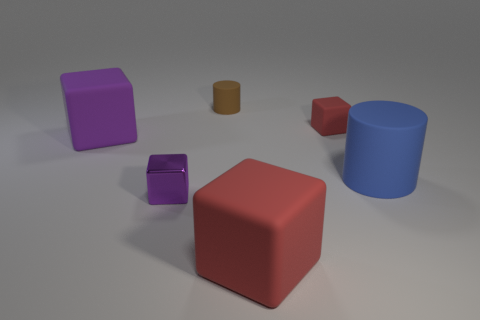How many blue objects are small rubber objects or objects?
Give a very brief answer. 1. Does the large thing that is to the left of the large red object have the same shape as the red thing in front of the large cylinder?
Your answer should be compact. Yes. What number of other things are made of the same material as the tiny brown cylinder?
Keep it short and to the point. 4. Are there any blue cylinders right of the large rubber cube that is left of the matte cylinder that is to the left of the large red cube?
Your answer should be very brief. Yes. Are the large blue cylinder and the tiny purple cube made of the same material?
Provide a succinct answer. No. What material is the big block that is in front of the matte cube on the left side of the metal thing?
Offer a terse response. Rubber. There is a red cube in front of the tiny purple block; what is its size?
Make the answer very short. Large. There is a big thing that is both to the left of the tiny red block and behind the purple metal object; what is its color?
Keep it short and to the point. Purple. There is a matte block that is in front of the blue thing; does it have the same size as the brown cylinder?
Your answer should be compact. No. Are there any red matte blocks to the right of the large red object in front of the large purple object?
Make the answer very short. Yes. 